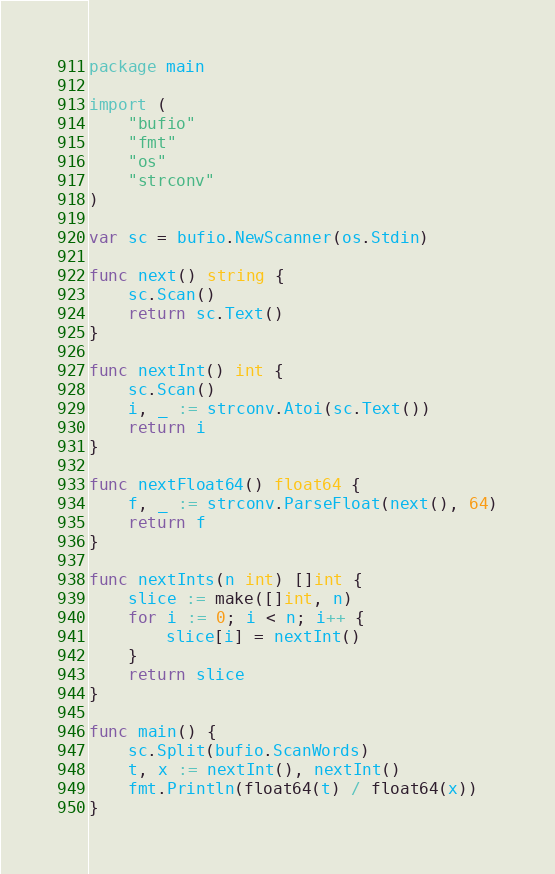<code> <loc_0><loc_0><loc_500><loc_500><_Go_>package main

import (
	"bufio"
	"fmt"
	"os"
	"strconv"
)

var sc = bufio.NewScanner(os.Stdin)

func next() string {
	sc.Scan()
	return sc.Text()
}

func nextInt() int {
	sc.Scan()
	i, _ := strconv.Atoi(sc.Text())
	return i
}

func nextFloat64() float64 {
	f, _ := strconv.ParseFloat(next(), 64)
	return f
}

func nextInts(n int) []int {
	slice := make([]int, n)
	for i := 0; i < n; i++ {
		slice[i] = nextInt()
	}
	return slice
}

func main() {
	sc.Split(bufio.ScanWords)
	t, x := nextInt(), nextInt()
	fmt.Println(float64(t) / float64(x))
}
</code> 